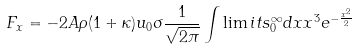Convert formula to latex. <formula><loc_0><loc_0><loc_500><loc_500>F _ { x } = - 2 A \rho ( 1 + \kappa ) u _ { 0 } \sigma \frac { 1 } { \sqrt { 2 \pi } } \int \lim i t s _ { 0 } ^ { \infty } d x x ^ { 3 } e ^ { - \frac { { x } ^ { 2 } } { 2 } }</formula> 